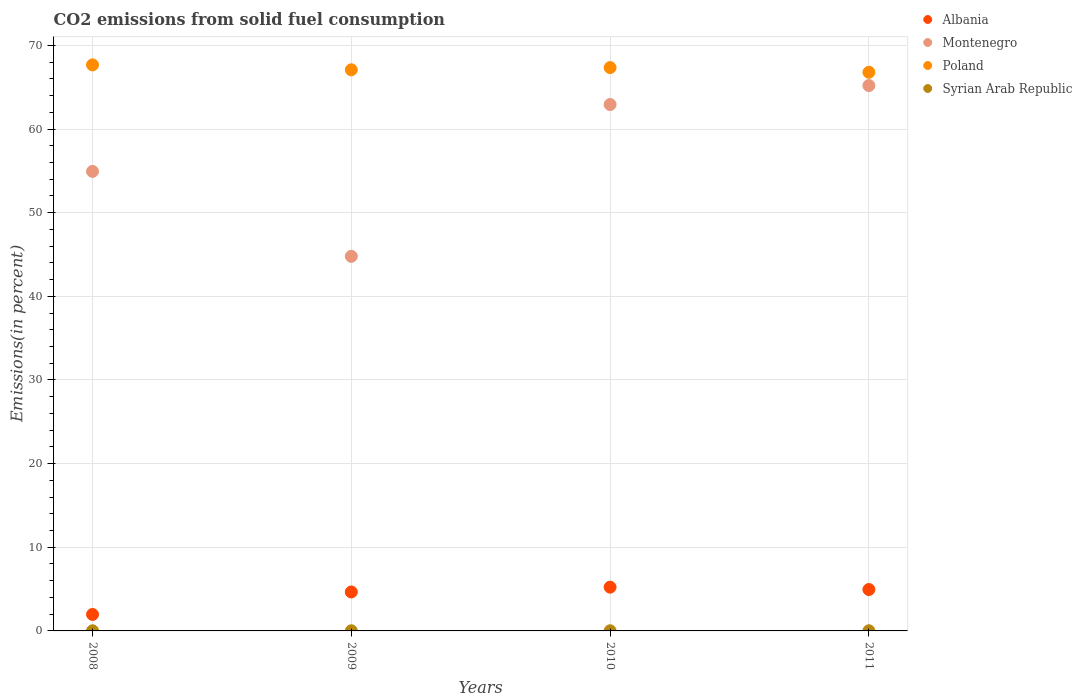Is the number of dotlines equal to the number of legend labels?
Provide a succinct answer. Yes. What is the total CO2 emitted in Syrian Arab Republic in 2011?
Provide a short and direct response. 0.02. Across all years, what is the maximum total CO2 emitted in Montenegro?
Your response must be concise. 65.19. Across all years, what is the minimum total CO2 emitted in Poland?
Your answer should be very brief. 66.78. In which year was the total CO2 emitted in Albania minimum?
Keep it short and to the point. 2008. What is the total total CO2 emitted in Albania in the graph?
Offer a terse response. 16.81. What is the difference between the total CO2 emitted in Poland in 2010 and that in 2011?
Provide a short and direct response. 0.56. What is the difference between the total CO2 emitted in Syrian Arab Republic in 2010 and the total CO2 emitted in Albania in 2009?
Your answer should be compact. -4.64. What is the average total CO2 emitted in Syrian Arab Republic per year?
Your response must be concise. 0.02. In the year 2009, what is the difference between the total CO2 emitted in Syrian Arab Republic and total CO2 emitted in Albania?
Your response must be concise. -4.64. In how many years, is the total CO2 emitted in Poland greater than 8 %?
Your answer should be compact. 4. What is the ratio of the total CO2 emitted in Poland in 2008 to that in 2011?
Your answer should be very brief. 1.01. Is the difference between the total CO2 emitted in Syrian Arab Republic in 2010 and 2011 greater than the difference between the total CO2 emitted in Albania in 2010 and 2011?
Provide a short and direct response. No. What is the difference between the highest and the second highest total CO2 emitted in Montenegro?
Provide a succinct answer. 2.27. What is the difference between the highest and the lowest total CO2 emitted in Syrian Arab Republic?
Provide a succinct answer. 0. In how many years, is the total CO2 emitted in Montenegro greater than the average total CO2 emitted in Montenegro taken over all years?
Provide a short and direct response. 2. Is the sum of the total CO2 emitted in Poland in 2009 and 2011 greater than the maximum total CO2 emitted in Syrian Arab Republic across all years?
Give a very brief answer. Yes. Is it the case that in every year, the sum of the total CO2 emitted in Syrian Arab Republic and total CO2 emitted in Poland  is greater than the total CO2 emitted in Albania?
Ensure brevity in your answer.  Yes. Does the total CO2 emitted in Poland monotonically increase over the years?
Keep it short and to the point. No. How many dotlines are there?
Ensure brevity in your answer.  4. What is the difference between two consecutive major ticks on the Y-axis?
Your answer should be very brief. 10. Are the values on the major ticks of Y-axis written in scientific E-notation?
Give a very brief answer. No. Does the graph contain any zero values?
Make the answer very short. No. Where does the legend appear in the graph?
Provide a short and direct response. Top right. What is the title of the graph?
Keep it short and to the point. CO2 emissions from solid fuel consumption. What is the label or title of the X-axis?
Provide a short and direct response. Years. What is the label or title of the Y-axis?
Your answer should be very brief. Emissions(in percent). What is the Emissions(in percent) in Albania in 2008?
Your answer should be very brief. 1.97. What is the Emissions(in percent) in Montenegro in 2008?
Your response must be concise. 54.93. What is the Emissions(in percent) of Poland in 2008?
Give a very brief answer. 67.67. What is the Emissions(in percent) of Syrian Arab Republic in 2008?
Your answer should be compact. 0.02. What is the Emissions(in percent) in Albania in 2009?
Provide a short and direct response. 4.66. What is the Emissions(in percent) of Montenegro in 2009?
Offer a terse response. 44.78. What is the Emissions(in percent) in Poland in 2009?
Offer a very short reply. 67.08. What is the Emissions(in percent) in Syrian Arab Republic in 2009?
Offer a very short reply. 0.02. What is the Emissions(in percent) in Albania in 2010?
Provide a succinct answer. 5.23. What is the Emissions(in percent) in Montenegro in 2010?
Ensure brevity in your answer.  62.93. What is the Emissions(in percent) in Poland in 2010?
Your answer should be very brief. 67.34. What is the Emissions(in percent) of Syrian Arab Republic in 2010?
Offer a very short reply. 0.02. What is the Emissions(in percent) of Albania in 2011?
Provide a succinct answer. 4.95. What is the Emissions(in percent) of Montenegro in 2011?
Provide a short and direct response. 65.19. What is the Emissions(in percent) of Poland in 2011?
Provide a short and direct response. 66.78. What is the Emissions(in percent) of Syrian Arab Republic in 2011?
Ensure brevity in your answer.  0.02. Across all years, what is the maximum Emissions(in percent) of Albania?
Give a very brief answer. 5.23. Across all years, what is the maximum Emissions(in percent) of Montenegro?
Offer a terse response. 65.19. Across all years, what is the maximum Emissions(in percent) of Poland?
Your answer should be compact. 67.67. Across all years, what is the maximum Emissions(in percent) in Syrian Arab Republic?
Offer a terse response. 0.02. Across all years, what is the minimum Emissions(in percent) in Albania?
Ensure brevity in your answer.  1.97. Across all years, what is the minimum Emissions(in percent) in Montenegro?
Ensure brevity in your answer.  44.78. Across all years, what is the minimum Emissions(in percent) in Poland?
Keep it short and to the point. 66.78. Across all years, what is the minimum Emissions(in percent) of Syrian Arab Republic?
Provide a succinct answer. 0.02. What is the total Emissions(in percent) of Albania in the graph?
Offer a very short reply. 16.81. What is the total Emissions(in percent) of Montenegro in the graph?
Offer a very short reply. 227.83. What is the total Emissions(in percent) of Poland in the graph?
Make the answer very short. 268.86. What is the total Emissions(in percent) of Syrian Arab Republic in the graph?
Make the answer very short. 0.07. What is the difference between the Emissions(in percent) in Albania in 2008 and that in 2009?
Offer a terse response. -2.69. What is the difference between the Emissions(in percent) of Montenegro in 2008 and that in 2009?
Your answer should be very brief. 10.15. What is the difference between the Emissions(in percent) of Poland in 2008 and that in 2009?
Make the answer very short. 0.59. What is the difference between the Emissions(in percent) in Syrian Arab Republic in 2008 and that in 2009?
Your response must be concise. -0. What is the difference between the Emissions(in percent) in Albania in 2008 and that in 2010?
Keep it short and to the point. -3.26. What is the difference between the Emissions(in percent) of Montenegro in 2008 and that in 2010?
Offer a very short reply. -7.99. What is the difference between the Emissions(in percent) in Poland in 2008 and that in 2010?
Offer a terse response. 0.32. What is the difference between the Emissions(in percent) of Syrian Arab Republic in 2008 and that in 2010?
Offer a very short reply. -0. What is the difference between the Emissions(in percent) of Albania in 2008 and that in 2011?
Ensure brevity in your answer.  -2.98. What is the difference between the Emissions(in percent) of Montenegro in 2008 and that in 2011?
Make the answer very short. -10.26. What is the difference between the Emissions(in percent) of Poland in 2008 and that in 2011?
Make the answer very short. 0.89. What is the difference between the Emissions(in percent) of Syrian Arab Republic in 2008 and that in 2011?
Keep it short and to the point. -0. What is the difference between the Emissions(in percent) in Albania in 2009 and that in 2010?
Keep it short and to the point. -0.58. What is the difference between the Emissions(in percent) in Montenegro in 2009 and that in 2010?
Keep it short and to the point. -18.15. What is the difference between the Emissions(in percent) of Poland in 2009 and that in 2010?
Offer a very short reply. -0.27. What is the difference between the Emissions(in percent) in Syrian Arab Republic in 2009 and that in 2010?
Provide a succinct answer. -0. What is the difference between the Emissions(in percent) of Albania in 2009 and that in 2011?
Your answer should be compact. -0.29. What is the difference between the Emissions(in percent) of Montenegro in 2009 and that in 2011?
Ensure brevity in your answer.  -20.41. What is the difference between the Emissions(in percent) in Poland in 2009 and that in 2011?
Ensure brevity in your answer.  0.29. What is the difference between the Emissions(in percent) in Syrian Arab Republic in 2009 and that in 2011?
Provide a short and direct response. -0. What is the difference between the Emissions(in percent) of Albania in 2010 and that in 2011?
Ensure brevity in your answer.  0.28. What is the difference between the Emissions(in percent) of Montenegro in 2010 and that in 2011?
Give a very brief answer. -2.27. What is the difference between the Emissions(in percent) of Poland in 2010 and that in 2011?
Ensure brevity in your answer.  0.56. What is the difference between the Emissions(in percent) in Syrian Arab Republic in 2010 and that in 2011?
Keep it short and to the point. -0. What is the difference between the Emissions(in percent) of Albania in 2008 and the Emissions(in percent) of Montenegro in 2009?
Your answer should be compact. -42.81. What is the difference between the Emissions(in percent) in Albania in 2008 and the Emissions(in percent) in Poland in 2009?
Provide a short and direct response. -65.11. What is the difference between the Emissions(in percent) in Albania in 2008 and the Emissions(in percent) in Syrian Arab Republic in 2009?
Your response must be concise. 1.95. What is the difference between the Emissions(in percent) of Montenegro in 2008 and the Emissions(in percent) of Poland in 2009?
Ensure brevity in your answer.  -12.14. What is the difference between the Emissions(in percent) in Montenegro in 2008 and the Emissions(in percent) in Syrian Arab Republic in 2009?
Your response must be concise. 54.92. What is the difference between the Emissions(in percent) in Poland in 2008 and the Emissions(in percent) in Syrian Arab Republic in 2009?
Your response must be concise. 67.65. What is the difference between the Emissions(in percent) in Albania in 2008 and the Emissions(in percent) in Montenegro in 2010?
Offer a terse response. -60.96. What is the difference between the Emissions(in percent) of Albania in 2008 and the Emissions(in percent) of Poland in 2010?
Make the answer very short. -65.37. What is the difference between the Emissions(in percent) of Albania in 2008 and the Emissions(in percent) of Syrian Arab Republic in 2010?
Ensure brevity in your answer.  1.95. What is the difference between the Emissions(in percent) of Montenegro in 2008 and the Emissions(in percent) of Poland in 2010?
Your answer should be compact. -12.41. What is the difference between the Emissions(in percent) in Montenegro in 2008 and the Emissions(in percent) in Syrian Arab Republic in 2010?
Your response must be concise. 54.92. What is the difference between the Emissions(in percent) in Poland in 2008 and the Emissions(in percent) in Syrian Arab Republic in 2010?
Provide a short and direct response. 67.65. What is the difference between the Emissions(in percent) of Albania in 2008 and the Emissions(in percent) of Montenegro in 2011?
Provide a short and direct response. -63.22. What is the difference between the Emissions(in percent) in Albania in 2008 and the Emissions(in percent) in Poland in 2011?
Your response must be concise. -64.81. What is the difference between the Emissions(in percent) of Albania in 2008 and the Emissions(in percent) of Syrian Arab Republic in 2011?
Your answer should be compact. 1.95. What is the difference between the Emissions(in percent) in Montenegro in 2008 and the Emissions(in percent) in Poland in 2011?
Ensure brevity in your answer.  -11.85. What is the difference between the Emissions(in percent) in Montenegro in 2008 and the Emissions(in percent) in Syrian Arab Republic in 2011?
Offer a terse response. 54.91. What is the difference between the Emissions(in percent) of Poland in 2008 and the Emissions(in percent) of Syrian Arab Republic in 2011?
Offer a terse response. 67.65. What is the difference between the Emissions(in percent) of Albania in 2009 and the Emissions(in percent) of Montenegro in 2010?
Offer a terse response. -58.27. What is the difference between the Emissions(in percent) of Albania in 2009 and the Emissions(in percent) of Poland in 2010?
Keep it short and to the point. -62.69. What is the difference between the Emissions(in percent) in Albania in 2009 and the Emissions(in percent) in Syrian Arab Republic in 2010?
Your answer should be very brief. 4.64. What is the difference between the Emissions(in percent) of Montenegro in 2009 and the Emissions(in percent) of Poland in 2010?
Ensure brevity in your answer.  -22.56. What is the difference between the Emissions(in percent) of Montenegro in 2009 and the Emissions(in percent) of Syrian Arab Republic in 2010?
Give a very brief answer. 44.76. What is the difference between the Emissions(in percent) in Poland in 2009 and the Emissions(in percent) in Syrian Arab Republic in 2010?
Offer a very short reply. 67.06. What is the difference between the Emissions(in percent) of Albania in 2009 and the Emissions(in percent) of Montenegro in 2011?
Give a very brief answer. -60.54. What is the difference between the Emissions(in percent) of Albania in 2009 and the Emissions(in percent) of Poland in 2011?
Give a very brief answer. -62.12. What is the difference between the Emissions(in percent) in Albania in 2009 and the Emissions(in percent) in Syrian Arab Republic in 2011?
Your answer should be compact. 4.64. What is the difference between the Emissions(in percent) of Montenegro in 2009 and the Emissions(in percent) of Poland in 2011?
Give a very brief answer. -22. What is the difference between the Emissions(in percent) of Montenegro in 2009 and the Emissions(in percent) of Syrian Arab Republic in 2011?
Give a very brief answer. 44.76. What is the difference between the Emissions(in percent) in Poland in 2009 and the Emissions(in percent) in Syrian Arab Republic in 2011?
Make the answer very short. 67.06. What is the difference between the Emissions(in percent) in Albania in 2010 and the Emissions(in percent) in Montenegro in 2011?
Ensure brevity in your answer.  -59.96. What is the difference between the Emissions(in percent) in Albania in 2010 and the Emissions(in percent) in Poland in 2011?
Your response must be concise. -61.55. What is the difference between the Emissions(in percent) of Albania in 2010 and the Emissions(in percent) of Syrian Arab Republic in 2011?
Provide a succinct answer. 5.21. What is the difference between the Emissions(in percent) of Montenegro in 2010 and the Emissions(in percent) of Poland in 2011?
Give a very brief answer. -3.85. What is the difference between the Emissions(in percent) in Montenegro in 2010 and the Emissions(in percent) in Syrian Arab Republic in 2011?
Your answer should be very brief. 62.91. What is the difference between the Emissions(in percent) of Poland in 2010 and the Emissions(in percent) of Syrian Arab Republic in 2011?
Give a very brief answer. 67.32. What is the average Emissions(in percent) in Albania per year?
Your response must be concise. 4.2. What is the average Emissions(in percent) in Montenegro per year?
Your answer should be compact. 56.96. What is the average Emissions(in percent) of Poland per year?
Your response must be concise. 67.22. What is the average Emissions(in percent) of Syrian Arab Republic per year?
Offer a terse response. 0.02. In the year 2008, what is the difference between the Emissions(in percent) in Albania and Emissions(in percent) in Montenegro?
Keep it short and to the point. -52.96. In the year 2008, what is the difference between the Emissions(in percent) in Albania and Emissions(in percent) in Poland?
Your answer should be very brief. -65.7. In the year 2008, what is the difference between the Emissions(in percent) in Albania and Emissions(in percent) in Syrian Arab Republic?
Keep it short and to the point. 1.95. In the year 2008, what is the difference between the Emissions(in percent) of Montenegro and Emissions(in percent) of Poland?
Your response must be concise. -12.73. In the year 2008, what is the difference between the Emissions(in percent) in Montenegro and Emissions(in percent) in Syrian Arab Republic?
Provide a short and direct response. 54.92. In the year 2008, what is the difference between the Emissions(in percent) of Poland and Emissions(in percent) of Syrian Arab Republic?
Keep it short and to the point. 67.65. In the year 2009, what is the difference between the Emissions(in percent) of Albania and Emissions(in percent) of Montenegro?
Offer a very short reply. -40.12. In the year 2009, what is the difference between the Emissions(in percent) of Albania and Emissions(in percent) of Poland?
Offer a terse response. -62.42. In the year 2009, what is the difference between the Emissions(in percent) of Albania and Emissions(in percent) of Syrian Arab Republic?
Your response must be concise. 4.64. In the year 2009, what is the difference between the Emissions(in percent) of Montenegro and Emissions(in percent) of Poland?
Provide a succinct answer. -22.3. In the year 2009, what is the difference between the Emissions(in percent) of Montenegro and Emissions(in percent) of Syrian Arab Republic?
Your response must be concise. 44.76. In the year 2009, what is the difference between the Emissions(in percent) of Poland and Emissions(in percent) of Syrian Arab Republic?
Keep it short and to the point. 67.06. In the year 2010, what is the difference between the Emissions(in percent) of Albania and Emissions(in percent) of Montenegro?
Your answer should be very brief. -57.69. In the year 2010, what is the difference between the Emissions(in percent) of Albania and Emissions(in percent) of Poland?
Ensure brevity in your answer.  -62.11. In the year 2010, what is the difference between the Emissions(in percent) in Albania and Emissions(in percent) in Syrian Arab Republic?
Your answer should be compact. 5.21. In the year 2010, what is the difference between the Emissions(in percent) of Montenegro and Emissions(in percent) of Poland?
Offer a terse response. -4.42. In the year 2010, what is the difference between the Emissions(in percent) of Montenegro and Emissions(in percent) of Syrian Arab Republic?
Make the answer very short. 62.91. In the year 2010, what is the difference between the Emissions(in percent) of Poland and Emissions(in percent) of Syrian Arab Republic?
Offer a very short reply. 67.32. In the year 2011, what is the difference between the Emissions(in percent) in Albania and Emissions(in percent) in Montenegro?
Keep it short and to the point. -60.24. In the year 2011, what is the difference between the Emissions(in percent) in Albania and Emissions(in percent) in Poland?
Your response must be concise. -61.83. In the year 2011, what is the difference between the Emissions(in percent) of Albania and Emissions(in percent) of Syrian Arab Republic?
Your response must be concise. 4.93. In the year 2011, what is the difference between the Emissions(in percent) in Montenegro and Emissions(in percent) in Poland?
Offer a very short reply. -1.59. In the year 2011, what is the difference between the Emissions(in percent) in Montenegro and Emissions(in percent) in Syrian Arab Republic?
Offer a very short reply. 65.17. In the year 2011, what is the difference between the Emissions(in percent) in Poland and Emissions(in percent) in Syrian Arab Republic?
Offer a very short reply. 66.76. What is the ratio of the Emissions(in percent) in Albania in 2008 to that in 2009?
Your response must be concise. 0.42. What is the ratio of the Emissions(in percent) in Montenegro in 2008 to that in 2009?
Give a very brief answer. 1.23. What is the ratio of the Emissions(in percent) of Poland in 2008 to that in 2009?
Offer a very short reply. 1.01. What is the ratio of the Emissions(in percent) of Syrian Arab Republic in 2008 to that in 2009?
Provide a succinct answer. 0.92. What is the ratio of the Emissions(in percent) in Albania in 2008 to that in 2010?
Offer a very short reply. 0.38. What is the ratio of the Emissions(in percent) in Montenegro in 2008 to that in 2010?
Offer a terse response. 0.87. What is the ratio of the Emissions(in percent) of Poland in 2008 to that in 2010?
Your answer should be compact. 1. What is the ratio of the Emissions(in percent) in Syrian Arab Republic in 2008 to that in 2010?
Your answer should be compact. 0.91. What is the ratio of the Emissions(in percent) in Albania in 2008 to that in 2011?
Your response must be concise. 0.4. What is the ratio of the Emissions(in percent) of Montenegro in 2008 to that in 2011?
Provide a succinct answer. 0.84. What is the ratio of the Emissions(in percent) in Poland in 2008 to that in 2011?
Give a very brief answer. 1.01. What is the ratio of the Emissions(in percent) in Syrian Arab Republic in 2008 to that in 2011?
Ensure brevity in your answer.  0.85. What is the ratio of the Emissions(in percent) in Albania in 2009 to that in 2010?
Offer a very short reply. 0.89. What is the ratio of the Emissions(in percent) in Montenegro in 2009 to that in 2010?
Your response must be concise. 0.71. What is the ratio of the Emissions(in percent) in Poland in 2009 to that in 2010?
Offer a very short reply. 1. What is the ratio of the Emissions(in percent) of Syrian Arab Republic in 2009 to that in 2010?
Your response must be concise. 0.99. What is the ratio of the Emissions(in percent) of Albania in 2009 to that in 2011?
Provide a succinct answer. 0.94. What is the ratio of the Emissions(in percent) in Montenegro in 2009 to that in 2011?
Keep it short and to the point. 0.69. What is the ratio of the Emissions(in percent) of Syrian Arab Republic in 2009 to that in 2011?
Your answer should be very brief. 0.93. What is the ratio of the Emissions(in percent) of Albania in 2010 to that in 2011?
Give a very brief answer. 1.06. What is the ratio of the Emissions(in percent) in Montenegro in 2010 to that in 2011?
Provide a short and direct response. 0.97. What is the ratio of the Emissions(in percent) in Poland in 2010 to that in 2011?
Give a very brief answer. 1.01. What is the ratio of the Emissions(in percent) of Syrian Arab Republic in 2010 to that in 2011?
Your response must be concise. 0.94. What is the difference between the highest and the second highest Emissions(in percent) of Albania?
Ensure brevity in your answer.  0.28. What is the difference between the highest and the second highest Emissions(in percent) in Montenegro?
Provide a short and direct response. 2.27. What is the difference between the highest and the second highest Emissions(in percent) in Poland?
Give a very brief answer. 0.32. What is the difference between the highest and the second highest Emissions(in percent) in Syrian Arab Republic?
Provide a succinct answer. 0. What is the difference between the highest and the lowest Emissions(in percent) in Albania?
Provide a succinct answer. 3.26. What is the difference between the highest and the lowest Emissions(in percent) in Montenegro?
Provide a succinct answer. 20.41. What is the difference between the highest and the lowest Emissions(in percent) of Poland?
Your response must be concise. 0.89. What is the difference between the highest and the lowest Emissions(in percent) of Syrian Arab Republic?
Offer a terse response. 0. 